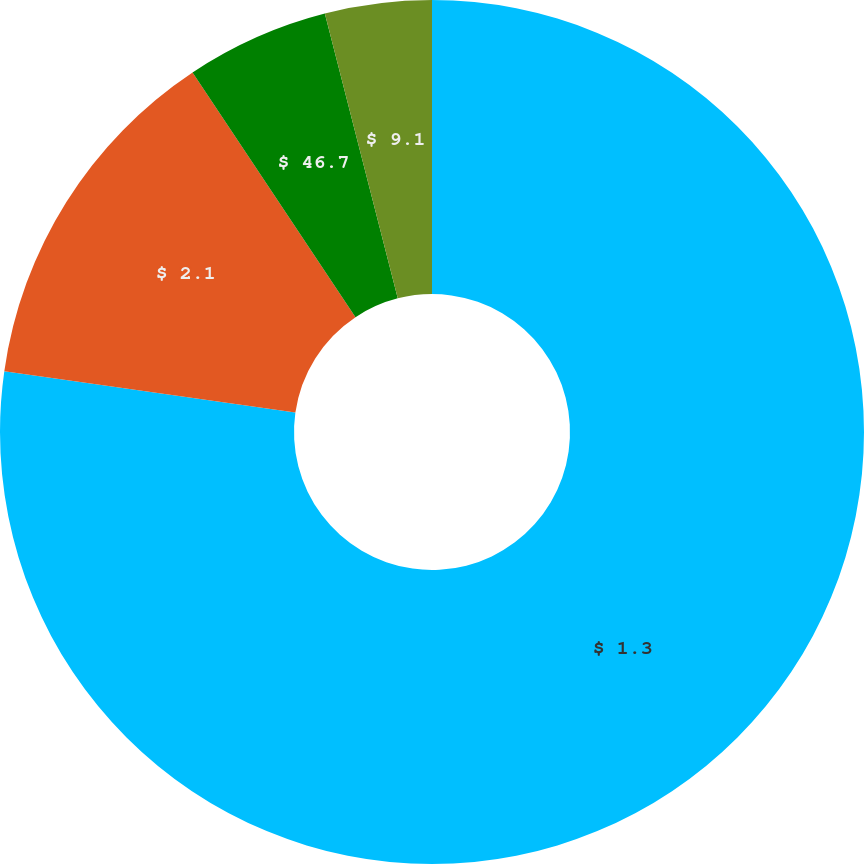<chart> <loc_0><loc_0><loc_500><loc_500><pie_chart><fcel>$ 1.3<fcel>$ 2.1<fcel>$ 46.7<fcel>$ 9.1<nl><fcel>77.25%<fcel>13.4%<fcel>5.36%<fcel>3.99%<nl></chart> 